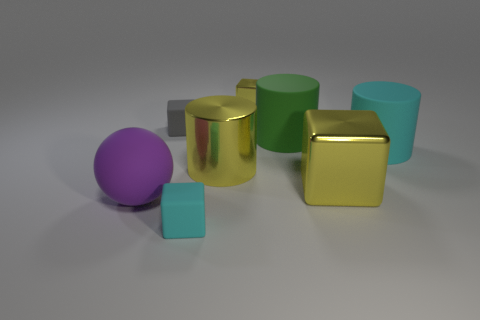Is the color of the metal cylinder the same as the tiny shiny block?
Your answer should be compact. Yes. Are there more purple shiny cubes than yellow metal cubes?
Your answer should be compact. No. Is there a small cyan matte object that has the same shape as the gray matte object?
Ensure brevity in your answer.  Yes. There is a yellow metallic thing that is behind the gray matte thing; what shape is it?
Offer a very short reply. Cube. What number of yellow metallic objects are to the left of the tiny matte object in front of the metal cube that is to the right of the small yellow cube?
Your answer should be very brief. 0. There is a small rubber thing behind the purple object; does it have the same color as the large cube?
Give a very brief answer. No. How many other things are there of the same shape as the green matte thing?
Offer a very short reply. 2. What number of other objects are there of the same material as the green cylinder?
Your answer should be very brief. 4. What is the material of the large thing on the right side of the yellow metallic block in front of the tiny yellow metal object that is to the left of the big green cylinder?
Offer a terse response. Rubber. Do the big yellow cylinder and the cyan cube have the same material?
Your response must be concise. No. 